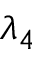<formula> <loc_0><loc_0><loc_500><loc_500>\lambda _ { 4 }</formula> 